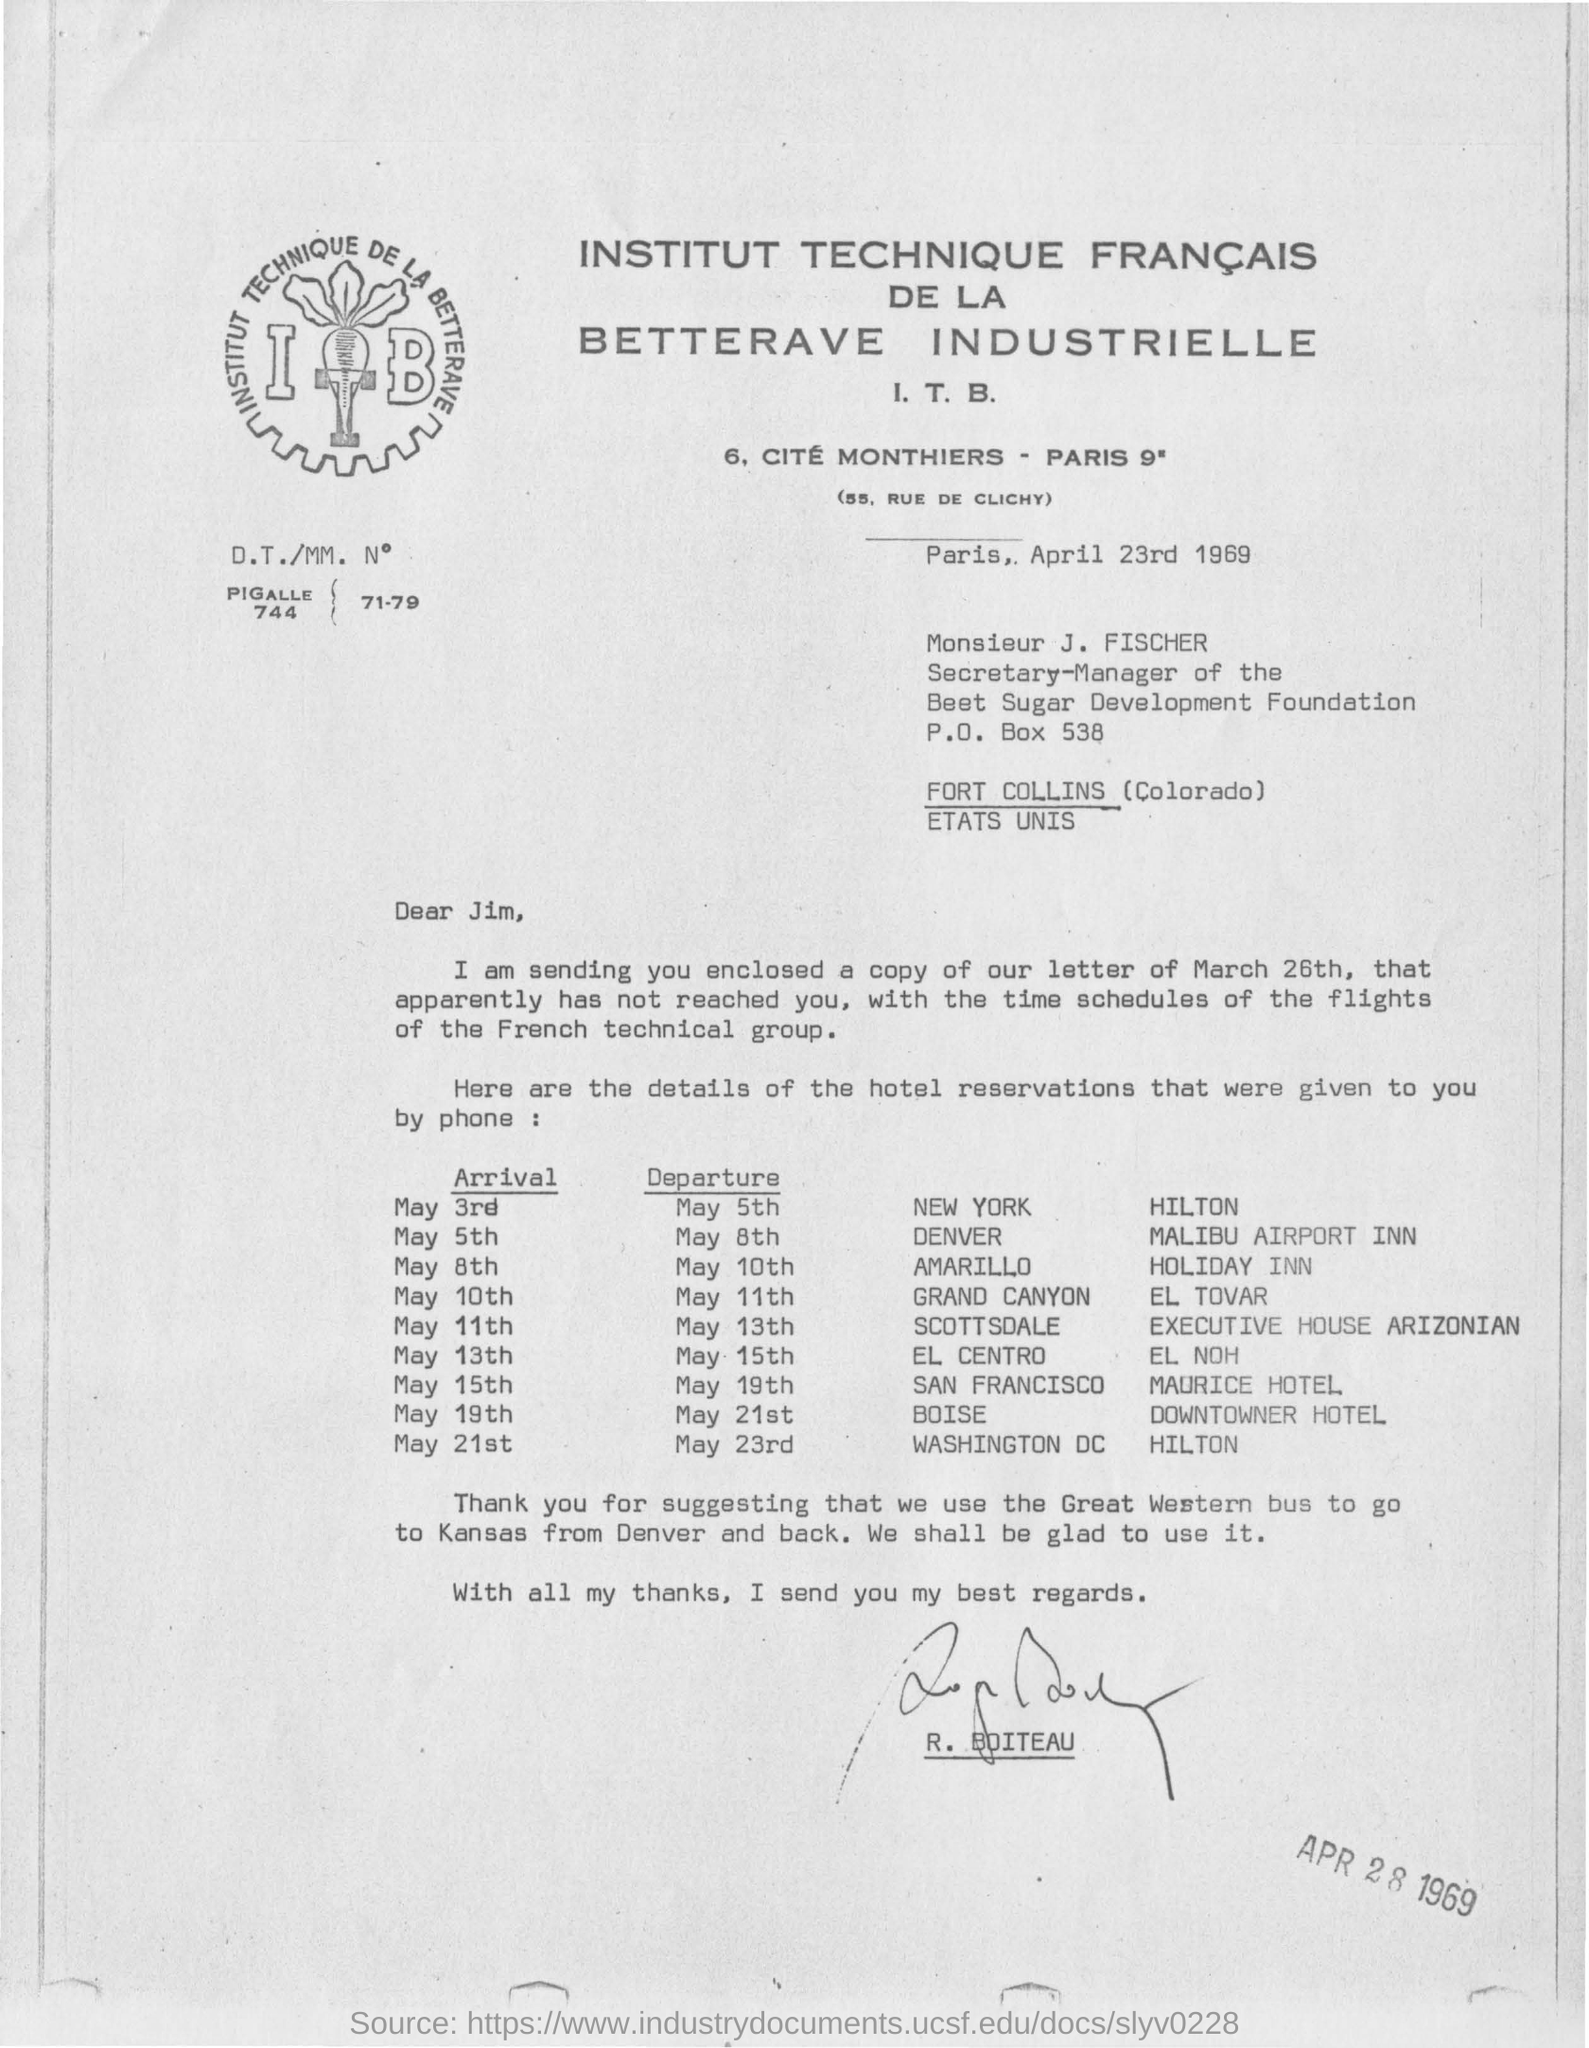Outline some significant characteristics in this image. The French technical group is responsible for flights. The letter was written to Jim. A Great Western bus is the preferred mode of transportation for traveling from Denver to Kansas, and vice versa. The Secretary-Manager of the Beet Sugar Development Foundation is Monsieur J. FISCHER. The hotel in New York is named Hilton. 